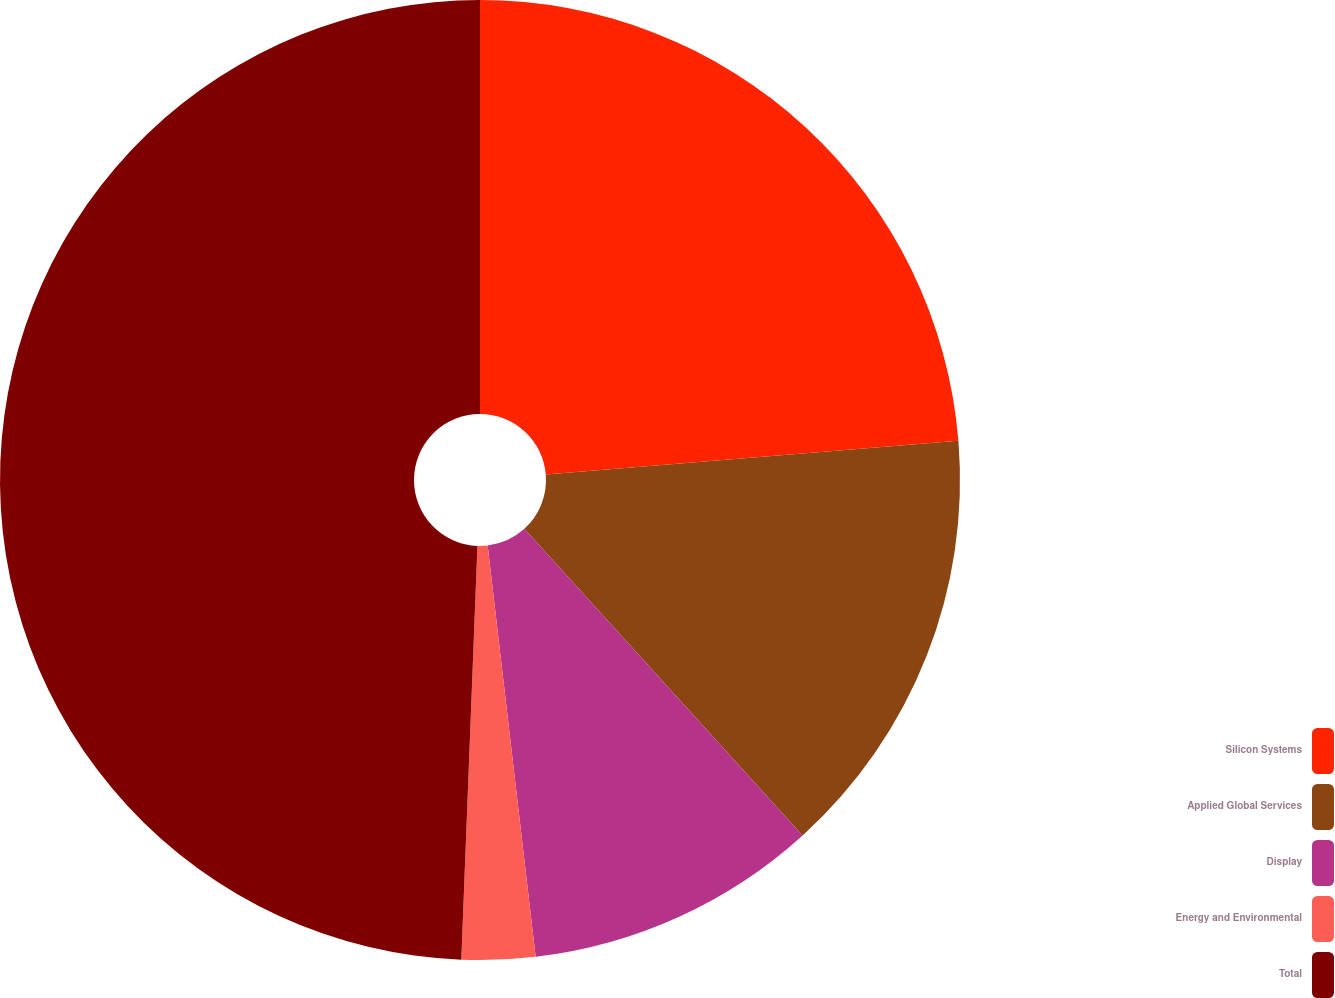Convert chart to OTSL. <chart><loc_0><loc_0><loc_500><loc_500><pie_chart><fcel>Silicon Systems<fcel>Applied Global Services<fcel>Display<fcel>Energy and Environmental<fcel>Total<nl><fcel>23.7%<fcel>14.57%<fcel>9.88%<fcel>2.47%<fcel>49.38%<nl></chart> 